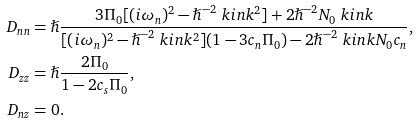Convert formula to latex. <formula><loc_0><loc_0><loc_500><loc_500>D _ { n n } & = \hslash \frac { 3 \Pi _ { 0 } [ ( i \omega _ { n } ) ^ { 2 } - \hslash ^ { - 2 } \ k i n k ^ { 2 } ] + 2 \hslash ^ { - 2 } N _ { 0 } \ k i n k } { [ ( i \omega _ { n } ) ^ { 2 } - \hslash ^ { - 2 } \ k i n k ^ { 2 } ] ( 1 - 3 c _ { n } \Pi _ { 0 } ) - 2 \hslash ^ { - 2 } \ k i n k N _ { 0 } c _ { n } } , \\ D _ { z z } & = \hslash \frac { 2 \Pi _ { 0 } } { 1 - 2 c _ { s } \Pi _ { 0 } } , \\ D _ { n z } & = 0 .</formula> 